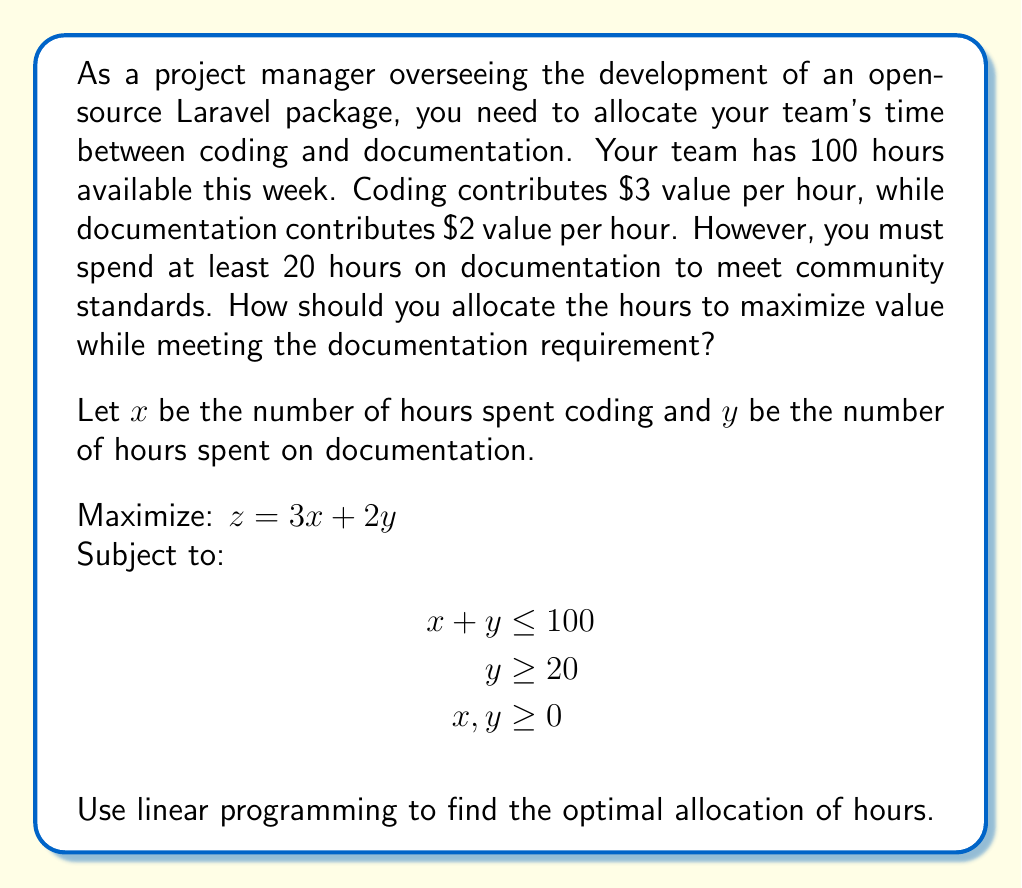Show me your answer to this math problem. To solve this linear programming problem, we'll use the graphical method:

1. Plot the constraints:
   - $x + y = 100$ (budget line)
   - $y = 20$ (minimum documentation requirement)
   - $x = 0$ and $y = 0$ (non-negativity constraints)

2. Identify the feasible region:
   The feasible region is the area that satisfies all constraints simultaneously.

3. Find the corner points of the feasible region:
   A: (0, 100)
   B: (0, 20)
   C: (80, 20)
   D: (0, 100)

4. Evaluate the objective function at each corner point:
   A: $z = 3(0) + 2(100) = 200$
   B: $z = 3(0) + 2(20) = 40$
   C: $z = 3(80) + 2(20) = 280$
   D: $z = 3(0) + 2(100) = 200$

5. Select the point with the maximum value:
   Point C (80, 20) gives the maximum value of 280.

Therefore, the optimal allocation is 80 hours for coding and 20 hours for documentation.

This solution aligns with the project manager's understanding of open-source technologies and supporting their partner's contributions to the Laravel community. It ensures that the minimum documentation requirement is met while maximizing the overall value produced by the team.
Answer: The optimal allocation is 80 hours for coding and 20 hours for documentation, resulting in a maximum value of $280. 